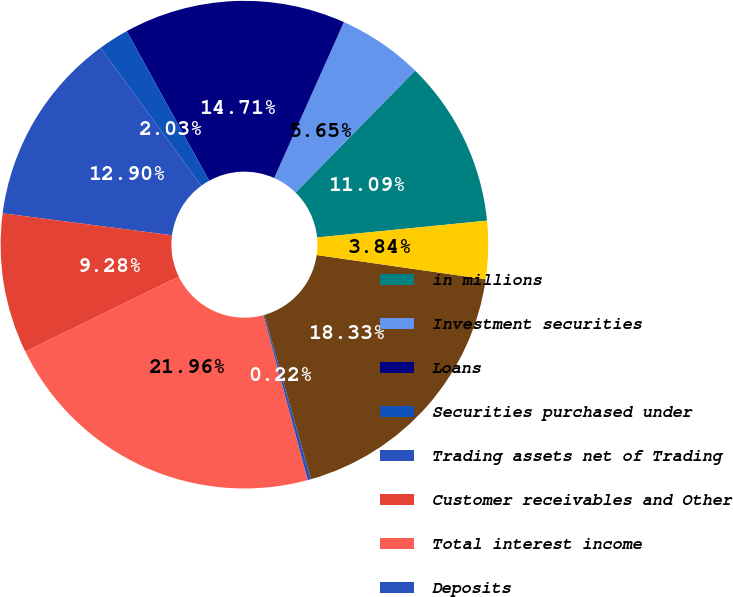Convert chart to OTSL. <chart><loc_0><loc_0><loc_500><loc_500><pie_chart><fcel>in millions<fcel>Investment securities<fcel>Loans<fcel>Securities purchased under<fcel>Trading assets net of Trading<fcel>Customer receivables and Other<fcel>Total interest income<fcel>Deposits<fcel>Borrowings<fcel>Securities sold under<nl><fcel>11.09%<fcel>5.65%<fcel>14.71%<fcel>2.03%<fcel>12.9%<fcel>9.28%<fcel>21.96%<fcel>0.22%<fcel>18.33%<fcel>3.84%<nl></chart> 